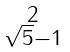Convert formula to latex. <formula><loc_0><loc_0><loc_500><loc_500>\begin{smallmatrix} 2 \\ \sqrt { 5 } - 1 \end{smallmatrix}</formula> 